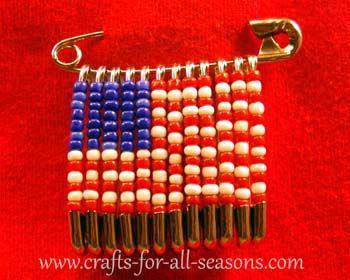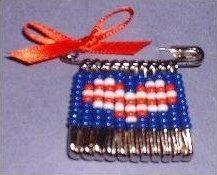The first image is the image on the left, the second image is the image on the right. Analyze the images presented: Is the assertion "An image includes a pin jewelry creation with beads that form a heart shape." valid? Answer yes or no. Yes. The first image is the image on the left, the second image is the image on the right. Evaluate the accuracy of this statement regarding the images: "At least one of the images displays a pin with a heart pennant.". Is it true? Answer yes or no. Yes. 